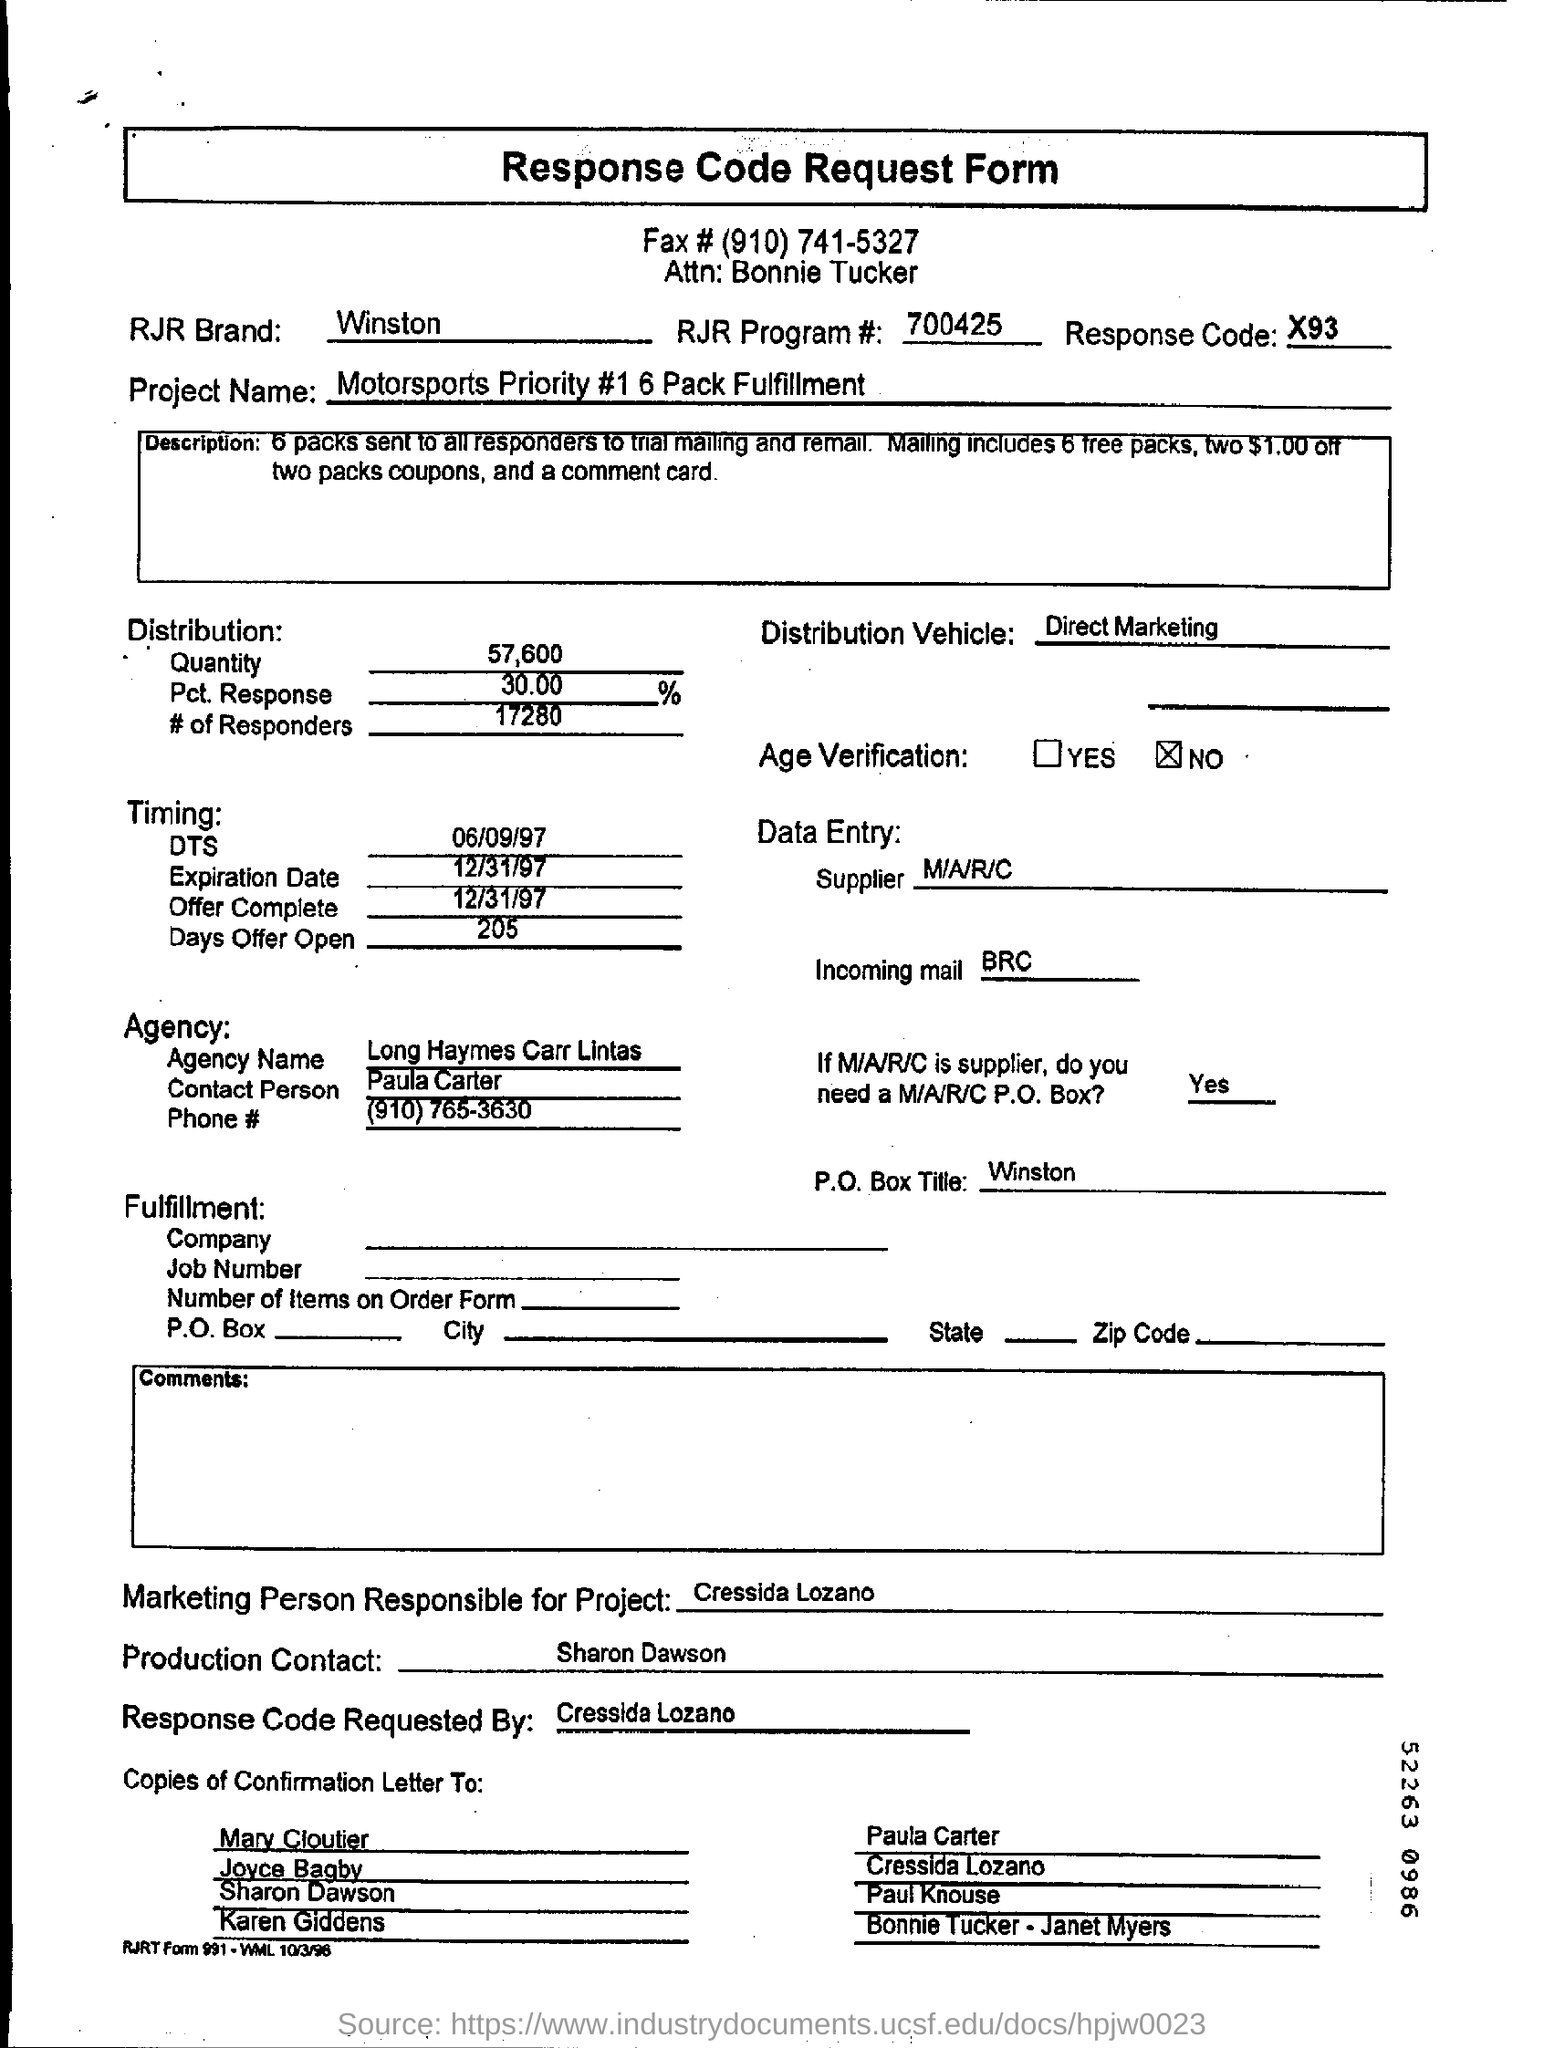What is the Title of the document?
Your answer should be compact. Response Code Request Form. What is the RJR Brand given in the form?
Offer a very short reply. Winston. Who is the Attn: to?
Offer a very short reply. Bonnie Tucker. What is the RJR Brand?
Your answer should be compact. Winston. What is the RJR Program #?
Your answer should be compact. 700425. What is the Response Code?
Your answer should be compact. X93. What is the Distribution vehicle?
Your answer should be compact. Direct Marketing. What is the Quantity?
Make the answer very short. 57,600. What is the Pct. Response?
Keep it short and to the point. 30.00 %. What is the # of Responders?
Make the answer very short. 17280. 